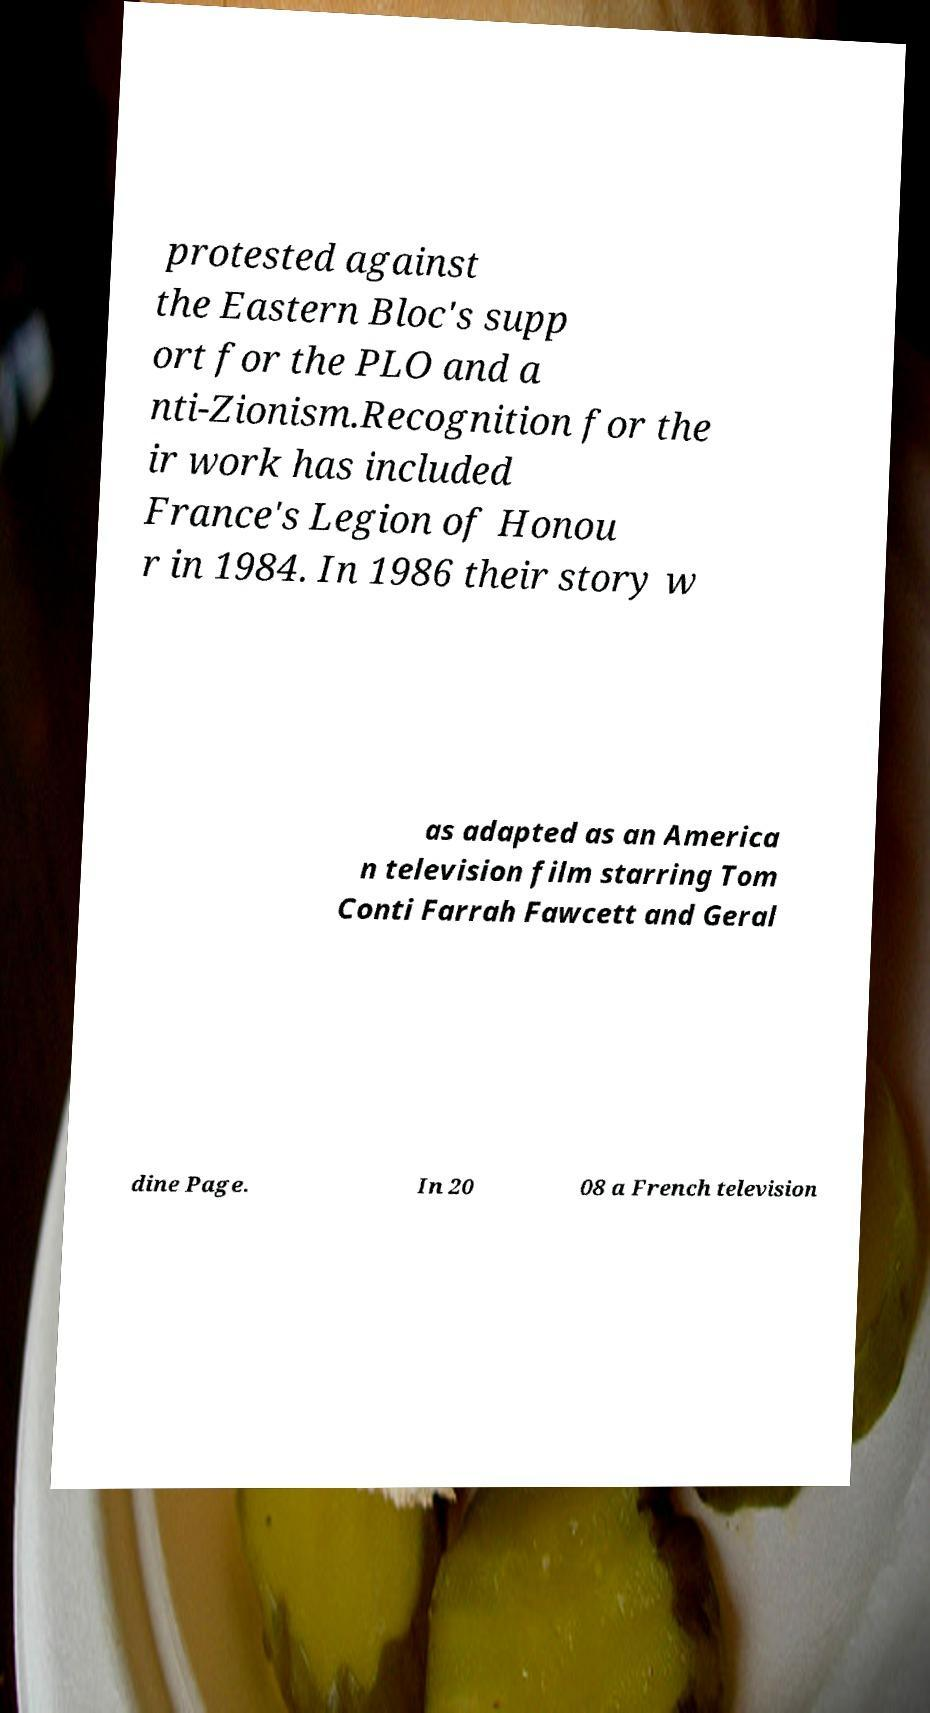Can you accurately transcribe the text from the provided image for me? protested against the Eastern Bloc's supp ort for the PLO and a nti-Zionism.Recognition for the ir work has included France's Legion of Honou r in 1984. In 1986 their story w as adapted as an America n television film starring Tom Conti Farrah Fawcett and Geral dine Page. In 20 08 a French television 